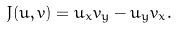Convert formula to latex. <formula><loc_0><loc_0><loc_500><loc_500>J ( u , v ) = u _ { x } v _ { y } - u _ { y } v _ { x } .</formula> 